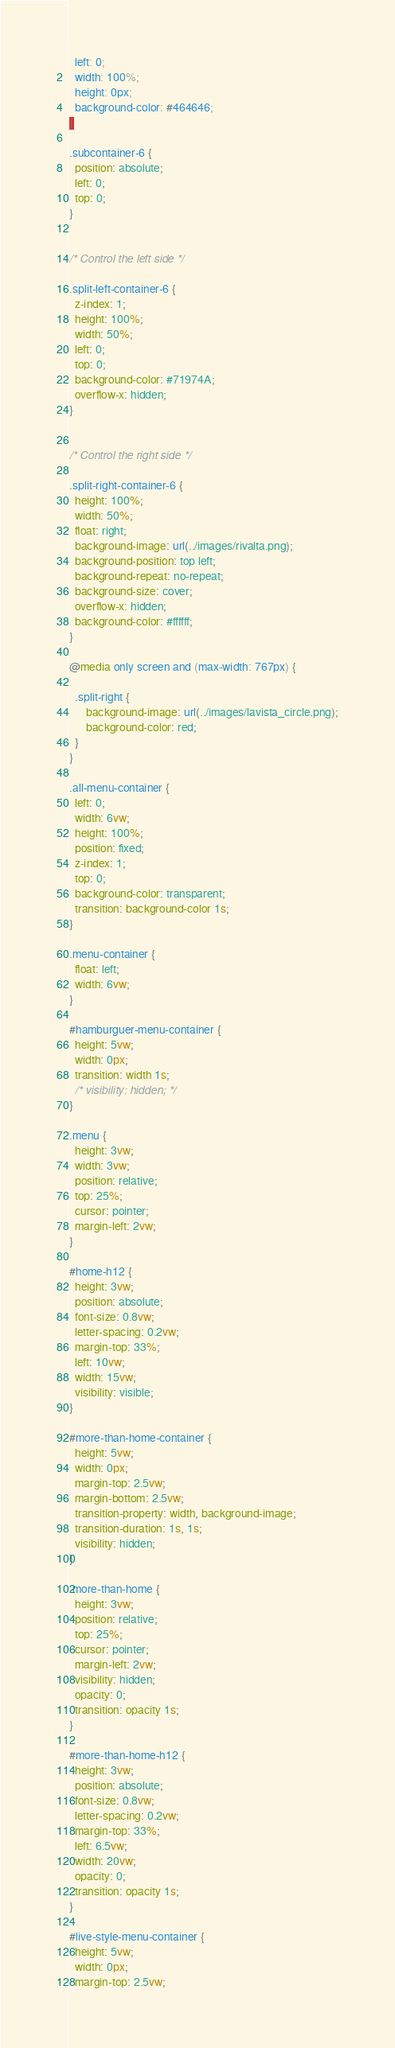<code> <loc_0><loc_0><loc_500><loc_500><_CSS_>  left: 0;
  width: 100%;
  height: 0px;
  background-color: #464646;
}

.subcontainer-6 {
  position: absolute;
  left: 0;
  top: 0;
}


/* Control the left side */

.split-left-container-6 {
  z-index: 1;
  height: 100%;
  width: 50%;
  left: 0;
  top: 0;
  background-color: #71974A;
  overflow-x: hidden;
}


/* Control the right side */

.split-right-container-6 {
  height: 100%;
  width: 50%;
  float: right;
  background-image: url(../images/rivalta.png);
  background-position: top left;
  background-repeat: no-repeat;
  background-size: cover;
  overflow-x: hidden;
  background-color: #ffffff;
}

@media only screen and (max-width: 767px) {
  
  .split-right {
      background-image: url(../images/lavista_circle.png);
      background-color: red;
  }
}

.all-menu-container {
  left: 0;
  width: 6vw;
  height: 100%;
  position: fixed;
  z-index: 1;
  top: 0;
  background-color: transparent;
  transition: background-color 1s;
}

.menu-container {
  float: left;
  width: 6vw;
}

#hamburguer-menu-container {
  height: 5vw;
  width: 0px;
  transition: width 1s;
  /* visibility: hidden; */
}

.menu {
  height: 3vw;
  width: 3vw;
  position: relative;
  top: 25%;
  cursor: pointer;
  margin-left: 2vw;
}

#home-h12 {
  height: 3vw;
  position: absolute;
  font-size: 0.8vw;
  letter-spacing: 0.2vw;
  margin-top: 33%;
  left: 10vw;
  width: 15vw;
  visibility: visible;
}

#more-than-home-container {
  height: 5vw;
  width: 0px;
  margin-top: 2.5vw;
  margin-bottom: 2.5vw;
  transition-property: width, background-image;
  transition-duration: 1s, 1s;
  visibility: hidden;
}

.more-than-home {
  height: 3vw;
  position: relative;
  top: 25%;
  cursor: pointer;
  margin-left: 2vw;
  visibility: hidden;
  opacity: 0;
  transition: opacity 1s;
}

#more-than-home-h12 {
  height: 3vw;
  position: absolute;
  font-size: 0.8vw;
  letter-spacing: 0.2vw;
  margin-top: 33%;
  left: 6.5vw;
  width: 20vw;
  opacity: 0;
  transition: opacity 1s;
}

#live-style-menu-container {
  height: 5vw;
  width: 0px;
  margin-top: 2.5vw;</code> 